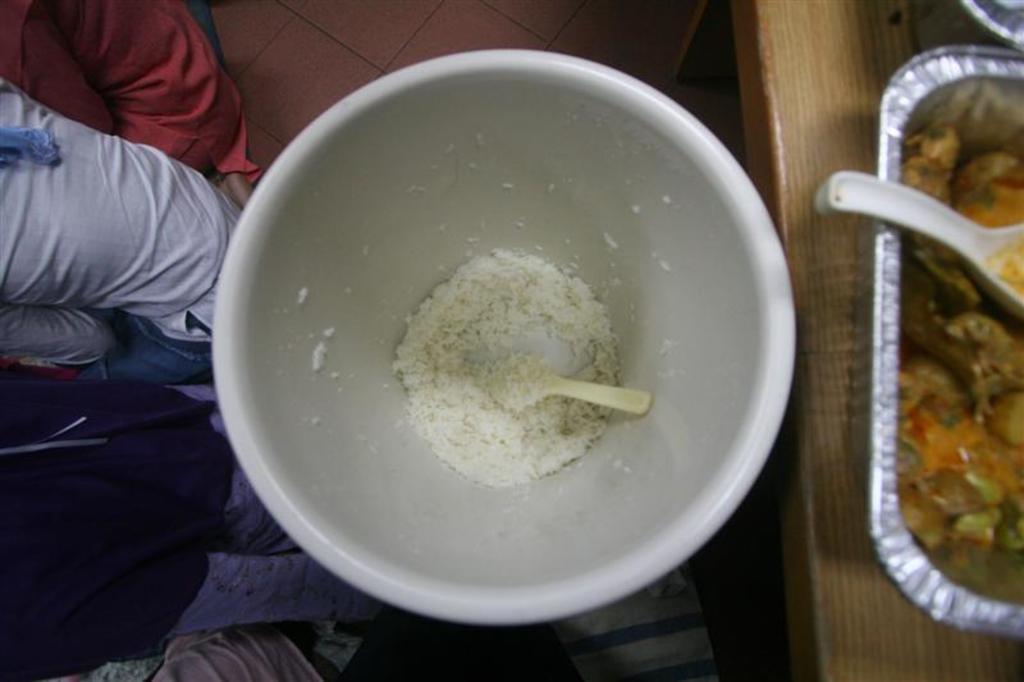Could you give a brief overview of what you see in this image? In this image there is a bowl of rice with a spoon in it, to the left of the bowl there is a person standing, to the right of the bowl on the table there is another curry in a bowl. 